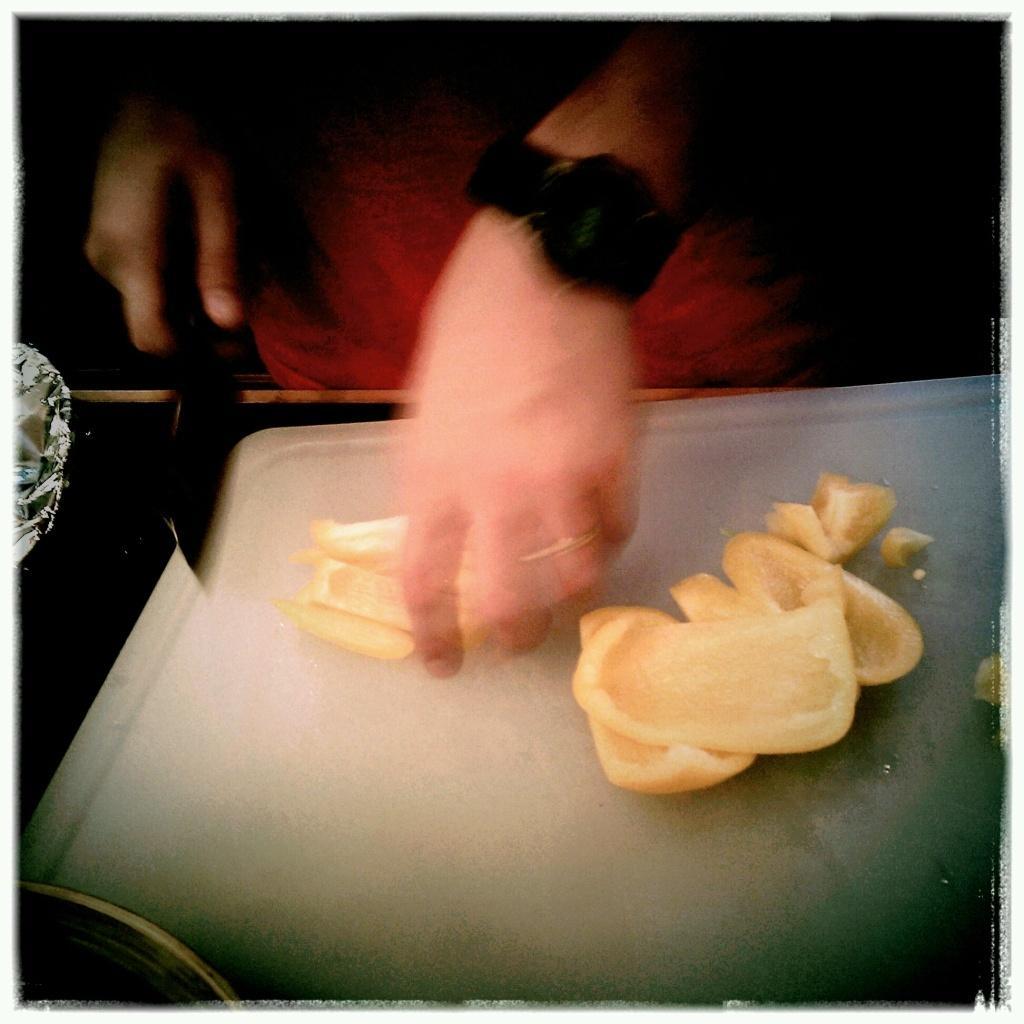Can you describe this image briefly? In this image I can see a person hand , on the hand I can see a black color watch and holding a knife and another hand holding a food item and I can see a white color tray in the foreground , on the tray I can see food item. 